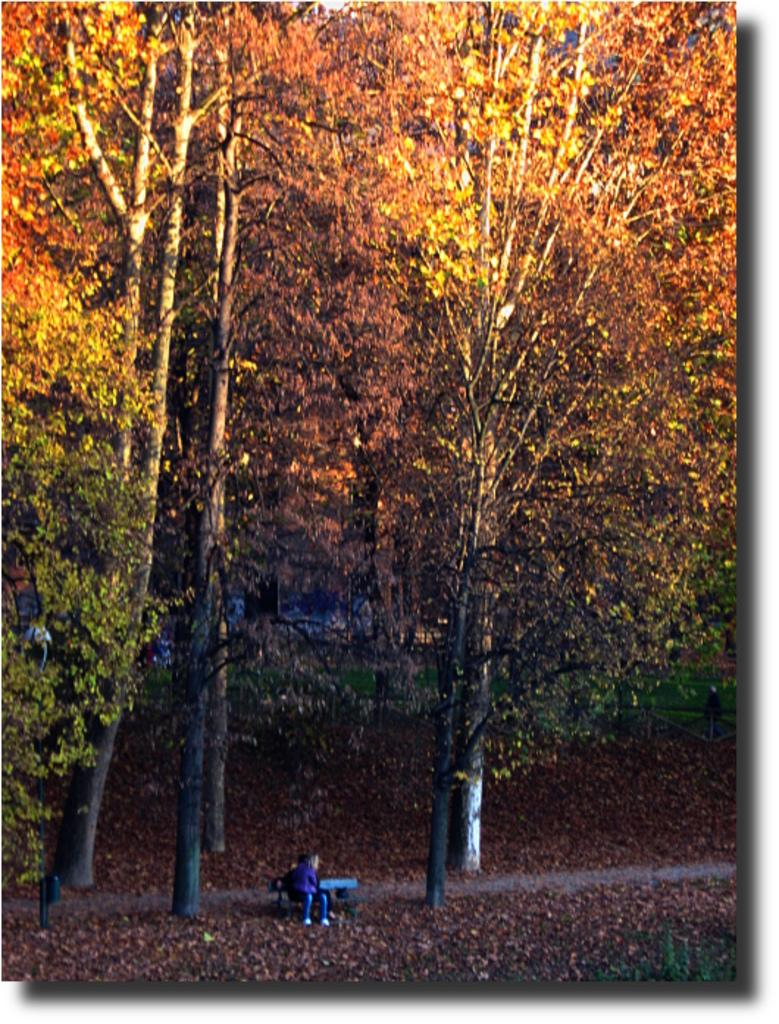What is the person in the image doing? The person is seated on a bench in the image. What can be seen in the background behind the person? There are trees visible behind the person. What is on the ground in the image? There are leaves on the ground in the image. What type of mist can be seen surrounding the person in the image? There is no mist present in the image; it is clear and the person is seated on a bench with trees in the background and leaves on the ground. 